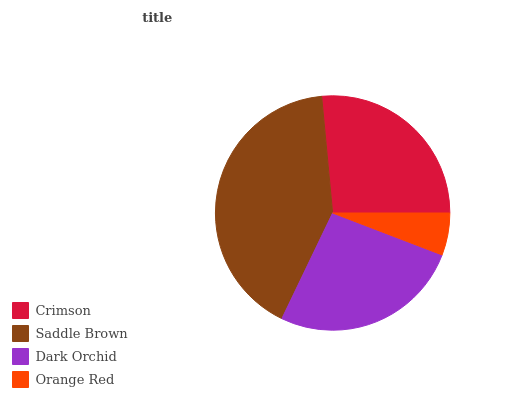Is Orange Red the minimum?
Answer yes or no. Yes. Is Saddle Brown the maximum?
Answer yes or no. Yes. Is Dark Orchid the minimum?
Answer yes or no. No. Is Dark Orchid the maximum?
Answer yes or no. No. Is Saddle Brown greater than Dark Orchid?
Answer yes or no. Yes. Is Dark Orchid less than Saddle Brown?
Answer yes or no. Yes. Is Dark Orchid greater than Saddle Brown?
Answer yes or no. No. Is Saddle Brown less than Dark Orchid?
Answer yes or no. No. Is Crimson the high median?
Answer yes or no. Yes. Is Dark Orchid the low median?
Answer yes or no. Yes. Is Saddle Brown the high median?
Answer yes or no. No. Is Crimson the low median?
Answer yes or no. No. 